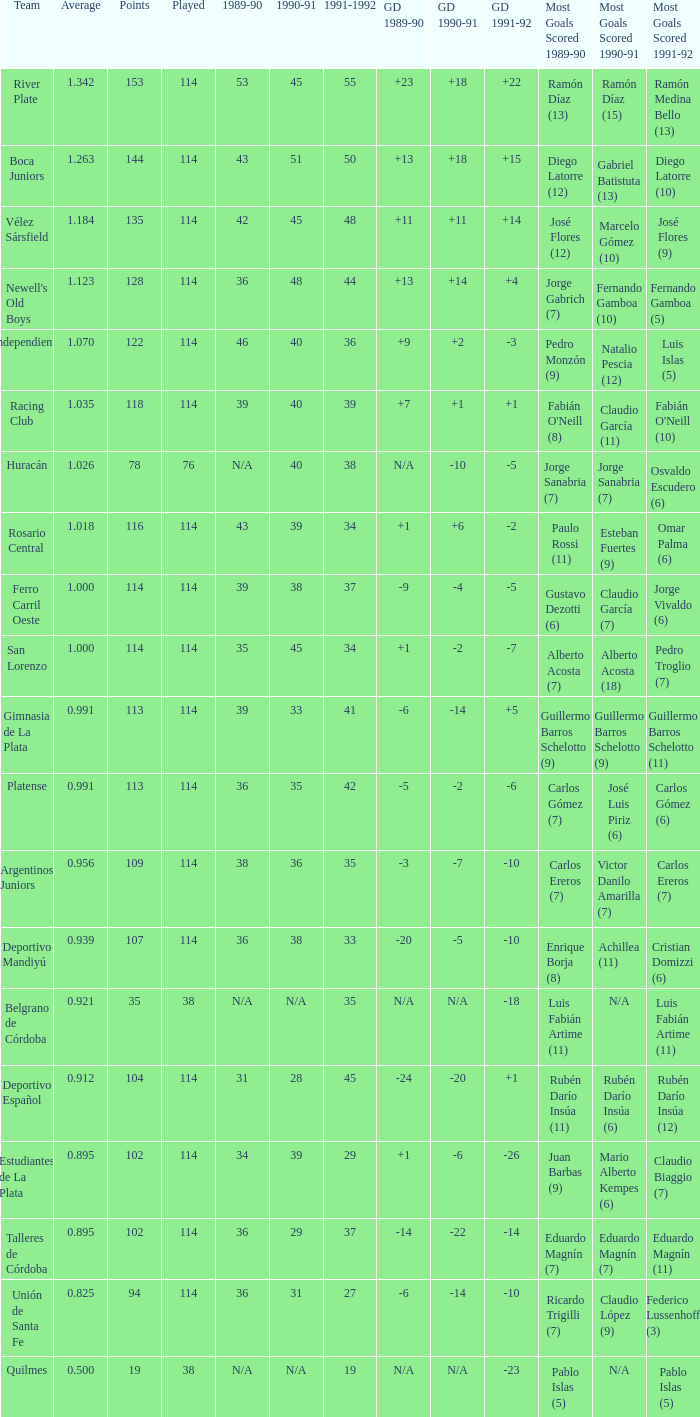How much 1991-1992 has a Team of gimnasia de la plata, and more than 113 points? 0.0. 